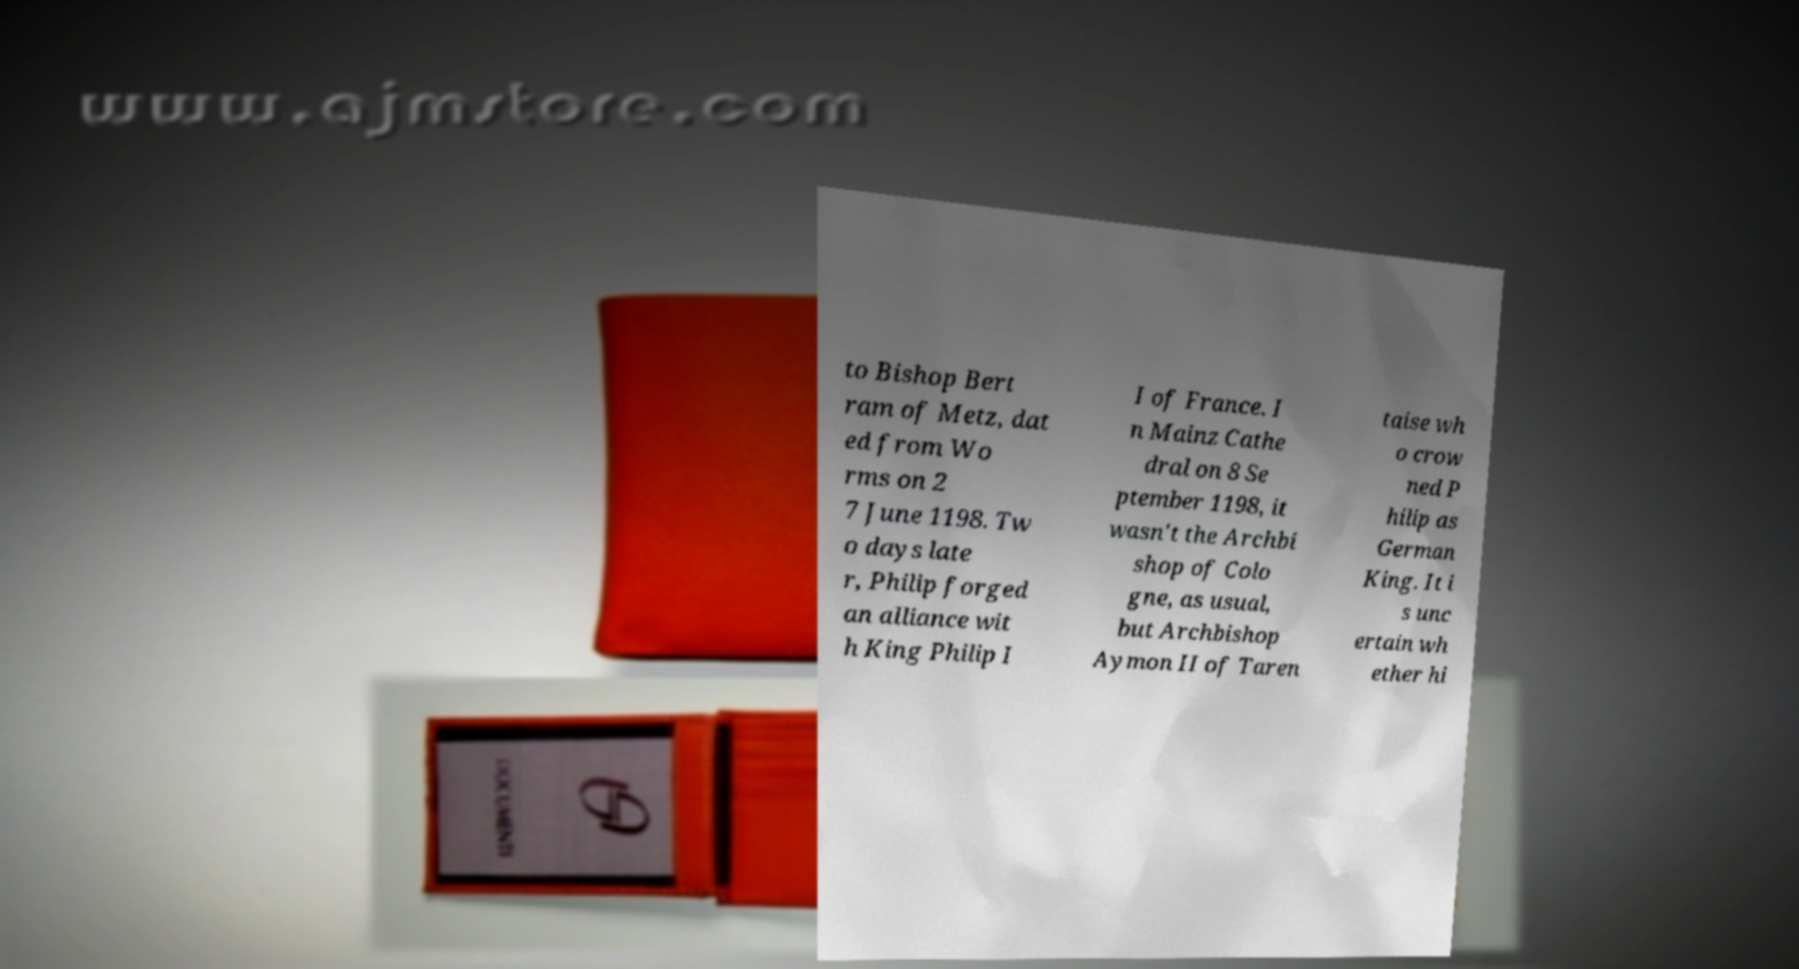Could you extract and type out the text from this image? to Bishop Bert ram of Metz, dat ed from Wo rms on 2 7 June 1198. Tw o days late r, Philip forged an alliance wit h King Philip I I of France. I n Mainz Cathe dral on 8 Se ptember 1198, it wasn't the Archbi shop of Colo gne, as usual, but Archbishop Aymon II of Taren taise wh o crow ned P hilip as German King. It i s unc ertain wh ether hi 